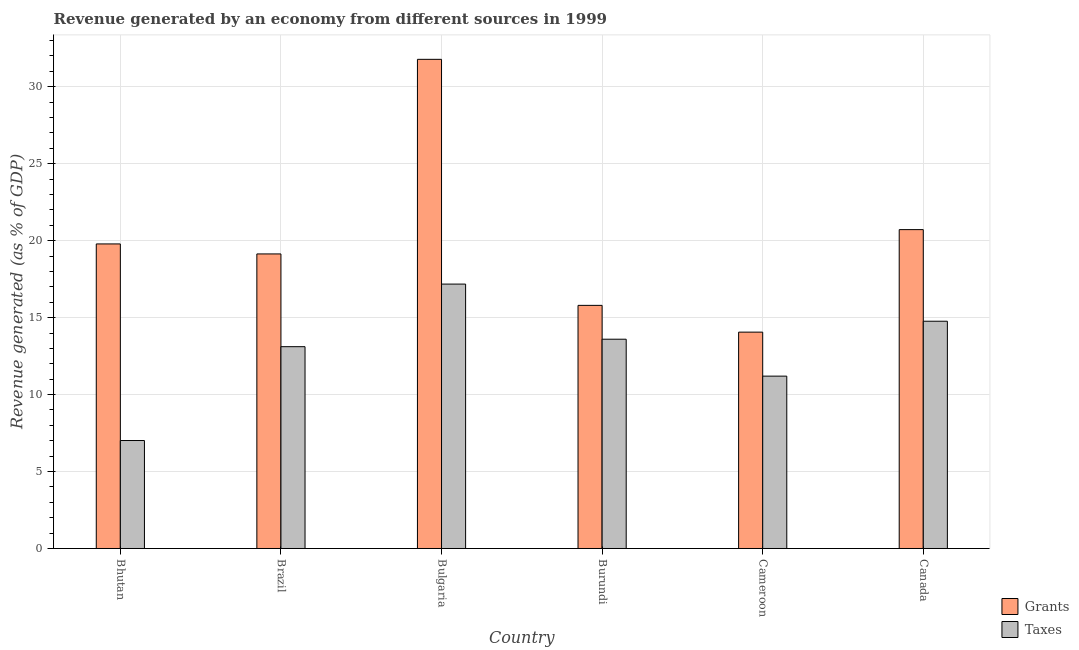How many different coloured bars are there?
Give a very brief answer. 2. Are the number of bars per tick equal to the number of legend labels?
Offer a terse response. Yes. How many bars are there on the 4th tick from the right?
Your answer should be compact. 2. What is the label of the 4th group of bars from the left?
Your response must be concise. Burundi. In how many cases, is the number of bars for a given country not equal to the number of legend labels?
Provide a short and direct response. 0. What is the revenue generated by taxes in Cameroon?
Ensure brevity in your answer.  11.2. Across all countries, what is the maximum revenue generated by taxes?
Offer a terse response. 17.18. Across all countries, what is the minimum revenue generated by taxes?
Offer a very short reply. 7.02. In which country was the revenue generated by grants minimum?
Your answer should be very brief. Cameroon. What is the total revenue generated by taxes in the graph?
Your answer should be very brief. 76.87. What is the difference between the revenue generated by grants in Burundi and that in Canada?
Ensure brevity in your answer.  -4.92. What is the difference between the revenue generated by taxes in Burundi and the revenue generated by grants in Cameroon?
Offer a terse response. -0.46. What is the average revenue generated by grants per country?
Ensure brevity in your answer.  20.21. What is the difference between the revenue generated by taxes and revenue generated by grants in Bulgaria?
Offer a terse response. -14.6. What is the ratio of the revenue generated by grants in Bhutan to that in Canada?
Offer a very short reply. 0.96. Is the difference between the revenue generated by grants in Cameroon and Canada greater than the difference between the revenue generated by taxes in Cameroon and Canada?
Your answer should be compact. No. What is the difference between the highest and the second highest revenue generated by taxes?
Your answer should be very brief. 2.41. What is the difference between the highest and the lowest revenue generated by taxes?
Offer a terse response. 10.16. Is the sum of the revenue generated by grants in Bulgaria and Burundi greater than the maximum revenue generated by taxes across all countries?
Keep it short and to the point. Yes. What does the 2nd bar from the left in Bulgaria represents?
Provide a succinct answer. Taxes. What does the 1st bar from the right in Burundi represents?
Your answer should be very brief. Taxes. Are all the bars in the graph horizontal?
Provide a short and direct response. No. How many countries are there in the graph?
Give a very brief answer. 6. What is the difference between two consecutive major ticks on the Y-axis?
Ensure brevity in your answer.  5. How many legend labels are there?
Your answer should be compact. 2. How are the legend labels stacked?
Provide a succinct answer. Vertical. What is the title of the graph?
Keep it short and to the point. Revenue generated by an economy from different sources in 1999. What is the label or title of the X-axis?
Offer a very short reply. Country. What is the label or title of the Y-axis?
Keep it short and to the point. Revenue generated (as % of GDP). What is the Revenue generated (as % of GDP) of Grants in Bhutan?
Offer a terse response. 19.79. What is the Revenue generated (as % of GDP) of Taxes in Bhutan?
Give a very brief answer. 7.02. What is the Revenue generated (as % of GDP) in Grants in Brazil?
Keep it short and to the point. 19.14. What is the Revenue generated (as % of GDP) in Taxes in Brazil?
Offer a very short reply. 13.11. What is the Revenue generated (as % of GDP) of Grants in Bulgaria?
Your answer should be very brief. 31.78. What is the Revenue generated (as % of GDP) in Taxes in Bulgaria?
Provide a short and direct response. 17.18. What is the Revenue generated (as % of GDP) of Grants in Burundi?
Offer a very short reply. 15.8. What is the Revenue generated (as % of GDP) of Taxes in Burundi?
Give a very brief answer. 13.6. What is the Revenue generated (as % of GDP) of Grants in Cameroon?
Offer a terse response. 14.06. What is the Revenue generated (as % of GDP) in Taxes in Cameroon?
Provide a succinct answer. 11.2. What is the Revenue generated (as % of GDP) in Grants in Canada?
Your answer should be very brief. 20.72. What is the Revenue generated (as % of GDP) of Taxes in Canada?
Provide a short and direct response. 14.77. Across all countries, what is the maximum Revenue generated (as % of GDP) in Grants?
Make the answer very short. 31.78. Across all countries, what is the maximum Revenue generated (as % of GDP) of Taxes?
Keep it short and to the point. 17.18. Across all countries, what is the minimum Revenue generated (as % of GDP) in Grants?
Your answer should be compact. 14.06. Across all countries, what is the minimum Revenue generated (as % of GDP) in Taxes?
Your answer should be compact. 7.02. What is the total Revenue generated (as % of GDP) of Grants in the graph?
Ensure brevity in your answer.  121.28. What is the total Revenue generated (as % of GDP) of Taxes in the graph?
Offer a very short reply. 76.87. What is the difference between the Revenue generated (as % of GDP) of Grants in Bhutan and that in Brazil?
Give a very brief answer. 0.65. What is the difference between the Revenue generated (as % of GDP) in Taxes in Bhutan and that in Brazil?
Ensure brevity in your answer.  -6.1. What is the difference between the Revenue generated (as % of GDP) of Grants in Bhutan and that in Bulgaria?
Ensure brevity in your answer.  -11.99. What is the difference between the Revenue generated (as % of GDP) in Taxes in Bhutan and that in Bulgaria?
Keep it short and to the point. -10.16. What is the difference between the Revenue generated (as % of GDP) of Grants in Bhutan and that in Burundi?
Your answer should be compact. 3.99. What is the difference between the Revenue generated (as % of GDP) of Taxes in Bhutan and that in Burundi?
Keep it short and to the point. -6.58. What is the difference between the Revenue generated (as % of GDP) in Grants in Bhutan and that in Cameroon?
Provide a succinct answer. 5.73. What is the difference between the Revenue generated (as % of GDP) in Taxes in Bhutan and that in Cameroon?
Make the answer very short. -4.18. What is the difference between the Revenue generated (as % of GDP) in Grants in Bhutan and that in Canada?
Your answer should be compact. -0.93. What is the difference between the Revenue generated (as % of GDP) of Taxes in Bhutan and that in Canada?
Keep it short and to the point. -7.75. What is the difference between the Revenue generated (as % of GDP) in Grants in Brazil and that in Bulgaria?
Give a very brief answer. -12.64. What is the difference between the Revenue generated (as % of GDP) of Taxes in Brazil and that in Bulgaria?
Offer a very short reply. -4.07. What is the difference between the Revenue generated (as % of GDP) in Grants in Brazil and that in Burundi?
Provide a short and direct response. 3.34. What is the difference between the Revenue generated (as % of GDP) of Taxes in Brazil and that in Burundi?
Keep it short and to the point. -0.48. What is the difference between the Revenue generated (as % of GDP) of Grants in Brazil and that in Cameroon?
Your answer should be very brief. 5.08. What is the difference between the Revenue generated (as % of GDP) of Taxes in Brazil and that in Cameroon?
Offer a very short reply. 1.91. What is the difference between the Revenue generated (as % of GDP) of Grants in Brazil and that in Canada?
Ensure brevity in your answer.  -1.58. What is the difference between the Revenue generated (as % of GDP) in Taxes in Brazil and that in Canada?
Provide a succinct answer. -1.65. What is the difference between the Revenue generated (as % of GDP) of Grants in Bulgaria and that in Burundi?
Ensure brevity in your answer.  15.99. What is the difference between the Revenue generated (as % of GDP) of Taxes in Bulgaria and that in Burundi?
Your response must be concise. 3.58. What is the difference between the Revenue generated (as % of GDP) in Grants in Bulgaria and that in Cameroon?
Offer a terse response. 17.72. What is the difference between the Revenue generated (as % of GDP) of Taxes in Bulgaria and that in Cameroon?
Keep it short and to the point. 5.98. What is the difference between the Revenue generated (as % of GDP) in Grants in Bulgaria and that in Canada?
Offer a very short reply. 11.06. What is the difference between the Revenue generated (as % of GDP) of Taxes in Bulgaria and that in Canada?
Your response must be concise. 2.41. What is the difference between the Revenue generated (as % of GDP) of Grants in Burundi and that in Cameroon?
Ensure brevity in your answer.  1.74. What is the difference between the Revenue generated (as % of GDP) in Taxes in Burundi and that in Cameroon?
Your response must be concise. 2.4. What is the difference between the Revenue generated (as % of GDP) in Grants in Burundi and that in Canada?
Keep it short and to the point. -4.92. What is the difference between the Revenue generated (as % of GDP) of Taxes in Burundi and that in Canada?
Offer a very short reply. -1.17. What is the difference between the Revenue generated (as % of GDP) in Grants in Cameroon and that in Canada?
Provide a succinct answer. -6.66. What is the difference between the Revenue generated (as % of GDP) in Taxes in Cameroon and that in Canada?
Give a very brief answer. -3.57. What is the difference between the Revenue generated (as % of GDP) of Grants in Bhutan and the Revenue generated (as % of GDP) of Taxes in Brazil?
Provide a short and direct response. 6.68. What is the difference between the Revenue generated (as % of GDP) in Grants in Bhutan and the Revenue generated (as % of GDP) in Taxes in Bulgaria?
Make the answer very short. 2.61. What is the difference between the Revenue generated (as % of GDP) of Grants in Bhutan and the Revenue generated (as % of GDP) of Taxes in Burundi?
Keep it short and to the point. 6.19. What is the difference between the Revenue generated (as % of GDP) in Grants in Bhutan and the Revenue generated (as % of GDP) in Taxes in Cameroon?
Give a very brief answer. 8.59. What is the difference between the Revenue generated (as % of GDP) of Grants in Bhutan and the Revenue generated (as % of GDP) of Taxes in Canada?
Make the answer very short. 5.02. What is the difference between the Revenue generated (as % of GDP) in Grants in Brazil and the Revenue generated (as % of GDP) in Taxes in Bulgaria?
Provide a succinct answer. 1.96. What is the difference between the Revenue generated (as % of GDP) in Grants in Brazil and the Revenue generated (as % of GDP) in Taxes in Burundi?
Keep it short and to the point. 5.54. What is the difference between the Revenue generated (as % of GDP) in Grants in Brazil and the Revenue generated (as % of GDP) in Taxes in Cameroon?
Make the answer very short. 7.94. What is the difference between the Revenue generated (as % of GDP) of Grants in Brazil and the Revenue generated (as % of GDP) of Taxes in Canada?
Your answer should be compact. 4.37. What is the difference between the Revenue generated (as % of GDP) of Grants in Bulgaria and the Revenue generated (as % of GDP) of Taxes in Burundi?
Offer a terse response. 18.18. What is the difference between the Revenue generated (as % of GDP) of Grants in Bulgaria and the Revenue generated (as % of GDP) of Taxes in Cameroon?
Ensure brevity in your answer.  20.58. What is the difference between the Revenue generated (as % of GDP) in Grants in Bulgaria and the Revenue generated (as % of GDP) in Taxes in Canada?
Make the answer very short. 17.02. What is the difference between the Revenue generated (as % of GDP) in Grants in Burundi and the Revenue generated (as % of GDP) in Taxes in Cameroon?
Provide a succinct answer. 4.6. What is the difference between the Revenue generated (as % of GDP) in Grants in Burundi and the Revenue generated (as % of GDP) in Taxes in Canada?
Offer a very short reply. 1.03. What is the difference between the Revenue generated (as % of GDP) in Grants in Cameroon and the Revenue generated (as % of GDP) in Taxes in Canada?
Provide a succinct answer. -0.71. What is the average Revenue generated (as % of GDP) in Grants per country?
Your answer should be very brief. 20.21. What is the average Revenue generated (as % of GDP) in Taxes per country?
Your response must be concise. 12.81. What is the difference between the Revenue generated (as % of GDP) in Grants and Revenue generated (as % of GDP) in Taxes in Bhutan?
Give a very brief answer. 12.77. What is the difference between the Revenue generated (as % of GDP) of Grants and Revenue generated (as % of GDP) of Taxes in Brazil?
Your response must be concise. 6.03. What is the difference between the Revenue generated (as % of GDP) of Grants and Revenue generated (as % of GDP) of Taxes in Bulgaria?
Provide a short and direct response. 14.6. What is the difference between the Revenue generated (as % of GDP) of Grants and Revenue generated (as % of GDP) of Taxes in Burundi?
Your response must be concise. 2.2. What is the difference between the Revenue generated (as % of GDP) in Grants and Revenue generated (as % of GDP) in Taxes in Cameroon?
Make the answer very short. 2.86. What is the difference between the Revenue generated (as % of GDP) in Grants and Revenue generated (as % of GDP) in Taxes in Canada?
Your response must be concise. 5.95. What is the ratio of the Revenue generated (as % of GDP) of Grants in Bhutan to that in Brazil?
Give a very brief answer. 1.03. What is the ratio of the Revenue generated (as % of GDP) in Taxes in Bhutan to that in Brazil?
Keep it short and to the point. 0.54. What is the ratio of the Revenue generated (as % of GDP) of Grants in Bhutan to that in Bulgaria?
Provide a short and direct response. 0.62. What is the ratio of the Revenue generated (as % of GDP) of Taxes in Bhutan to that in Bulgaria?
Provide a short and direct response. 0.41. What is the ratio of the Revenue generated (as % of GDP) in Grants in Bhutan to that in Burundi?
Give a very brief answer. 1.25. What is the ratio of the Revenue generated (as % of GDP) of Taxes in Bhutan to that in Burundi?
Your answer should be compact. 0.52. What is the ratio of the Revenue generated (as % of GDP) in Grants in Bhutan to that in Cameroon?
Make the answer very short. 1.41. What is the ratio of the Revenue generated (as % of GDP) in Taxes in Bhutan to that in Cameroon?
Offer a terse response. 0.63. What is the ratio of the Revenue generated (as % of GDP) of Grants in Bhutan to that in Canada?
Ensure brevity in your answer.  0.96. What is the ratio of the Revenue generated (as % of GDP) of Taxes in Bhutan to that in Canada?
Your answer should be very brief. 0.48. What is the ratio of the Revenue generated (as % of GDP) of Grants in Brazil to that in Bulgaria?
Your answer should be very brief. 0.6. What is the ratio of the Revenue generated (as % of GDP) of Taxes in Brazil to that in Bulgaria?
Ensure brevity in your answer.  0.76. What is the ratio of the Revenue generated (as % of GDP) of Grants in Brazil to that in Burundi?
Give a very brief answer. 1.21. What is the ratio of the Revenue generated (as % of GDP) in Grants in Brazil to that in Cameroon?
Provide a succinct answer. 1.36. What is the ratio of the Revenue generated (as % of GDP) in Taxes in Brazil to that in Cameroon?
Provide a succinct answer. 1.17. What is the ratio of the Revenue generated (as % of GDP) in Grants in Brazil to that in Canada?
Offer a very short reply. 0.92. What is the ratio of the Revenue generated (as % of GDP) in Taxes in Brazil to that in Canada?
Make the answer very short. 0.89. What is the ratio of the Revenue generated (as % of GDP) in Grants in Bulgaria to that in Burundi?
Your response must be concise. 2.01. What is the ratio of the Revenue generated (as % of GDP) in Taxes in Bulgaria to that in Burundi?
Offer a very short reply. 1.26. What is the ratio of the Revenue generated (as % of GDP) in Grants in Bulgaria to that in Cameroon?
Offer a very short reply. 2.26. What is the ratio of the Revenue generated (as % of GDP) in Taxes in Bulgaria to that in Cameroon?
Provide a short and direct response. 1.53. What is the ratio of the Revenue generated (as % of GDP) of Grants in Bulgaria to that in Canada?
Provide a succinct answer. 1.53. What is the ratio of the Revenue generated (as % of GDP) of Taxes in Bulgaria to that in Canada?
Your answer should be compact. 1.16. What is the ratio of the Revenue generated (as % of GDP) in Grants in Burundi to that in Cameroon?
Make the answer very short. 1.12. What is the ratio of the Revenue generated (as % of GDP) in Taxes in Burundi to that in Cameroon?
Provide a short and direct response. 1.21. What is the ratio of the Revenue generated (as % of GDP) in Grants in Burundi to that in Canada?
Your answer should be compact. 0.76. What is the ratio of the Revenue generated (as % of GDP) in Taxes in Burundi to that in Canada?
Your answer should be very brief. 0.92. What is the ratio of the Revenue generated (as % of GDP) in Grants in Cameroon to that in Canada?
Ensure brevity in your answer.  0.68. What is the ratio of the Revenue generated (as % of GDP) of Taxes in Cameroon to that in Canada?
Give a very brief answer. 0.76. What is the difference between the highest and the second highest Revenue generated (as % of GDP) in Grants?
Provide a succinct answer. 11.06. What is the difference between the highest and the second highest Revenue generated (as % of GDP) in Taxes?
Your answer should be compact. 2.41. What is the difference between the highest and the lowest Revenue generated (as % of GDP) of Grants?
Provide a succinct answer. 17.72. What is the difference between the highest and the lowest Revenue generated (as % of GDP) in Taxes?
Give a very brief answer. 10.16. 